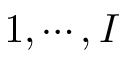<formula> <loc_0><loc_0><loc_500><loc_500>1 , \cdots , I</formula> 